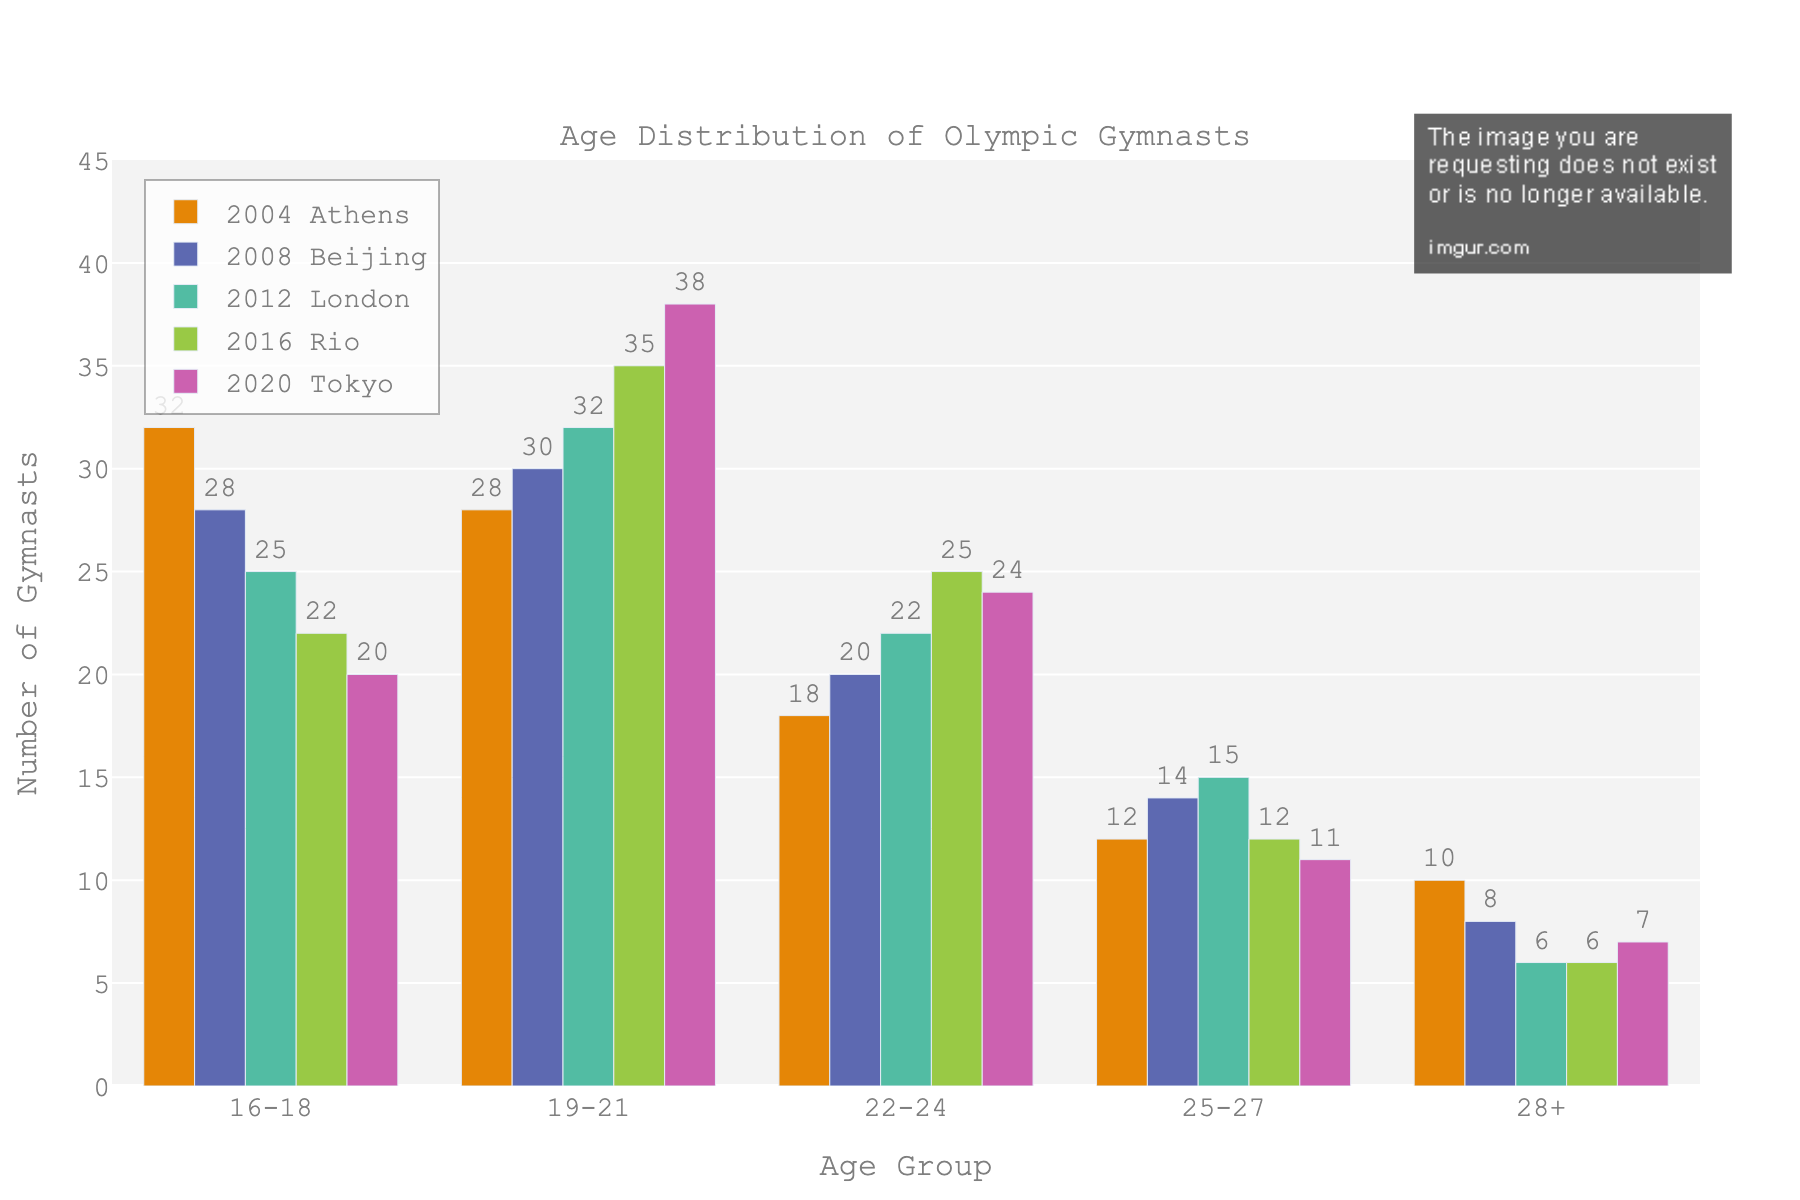What's the total number of gymnasts in the 19-21 age group for all 5 Olympic Games combined? Add the number of gymnasts in the 19-21 age group for each year: 28 (Athens) + 30 (Beijing) + 32 (London) + 35 (Rio) + 38 (Tokyo) = 163.
Answer: 163 Which age group had the highest number of gymnasts in the 2016 Rio Olympics? Observe the bar heights for the 2016 column. The 19-21 age group has the tallest bar.
Answer: 19-21 How did the number of gymnasts in the 16-18 age group change from the 2004 Athens to the 2020 Tokyo Olympics? Subtract the number of gymnasts in 2020 from the number in 2004: 32 (Athens) - 20 (Tokyo) = 12.
Answer: Decreased by 12 Which year had the smallest number of gymnasts aged 28+? Compare the bar heights for the 28+ age group across the years. 2012 London has the smallest bar with 6 gymnasts.
Answer: 2012 In which Olympic year was there a peak number of gymnasts in the 22-24 age group? Check the bar heights for the 22-24 age group. The peak is in 2016 Rio with 25 gymnasts.
Answer: 2016 Compare the total number of gymnasts in the 25-27 and 28+ age groups across all 5 Olympic Games. Which group had more gymnasts in total? Sum the number of gymnasts for each age group: 25-27: 12 + 14 + 15 + 12 + 11 = 64, 28+: 10 + 8 + 6 + 6 + 7 = 37. The 25-27 age group had more gymnasts.
Answer: 25-27 What is the general trend in the number of gymnasts in the 16-18 age group over the five Olympic Games? Observe the pattern over the years: 32 (Athens), 28 (Beijing), 25 (London), 22 (Rio), 20 (Tokyo). The number is decreasing.
Answer: Decreasing trend 